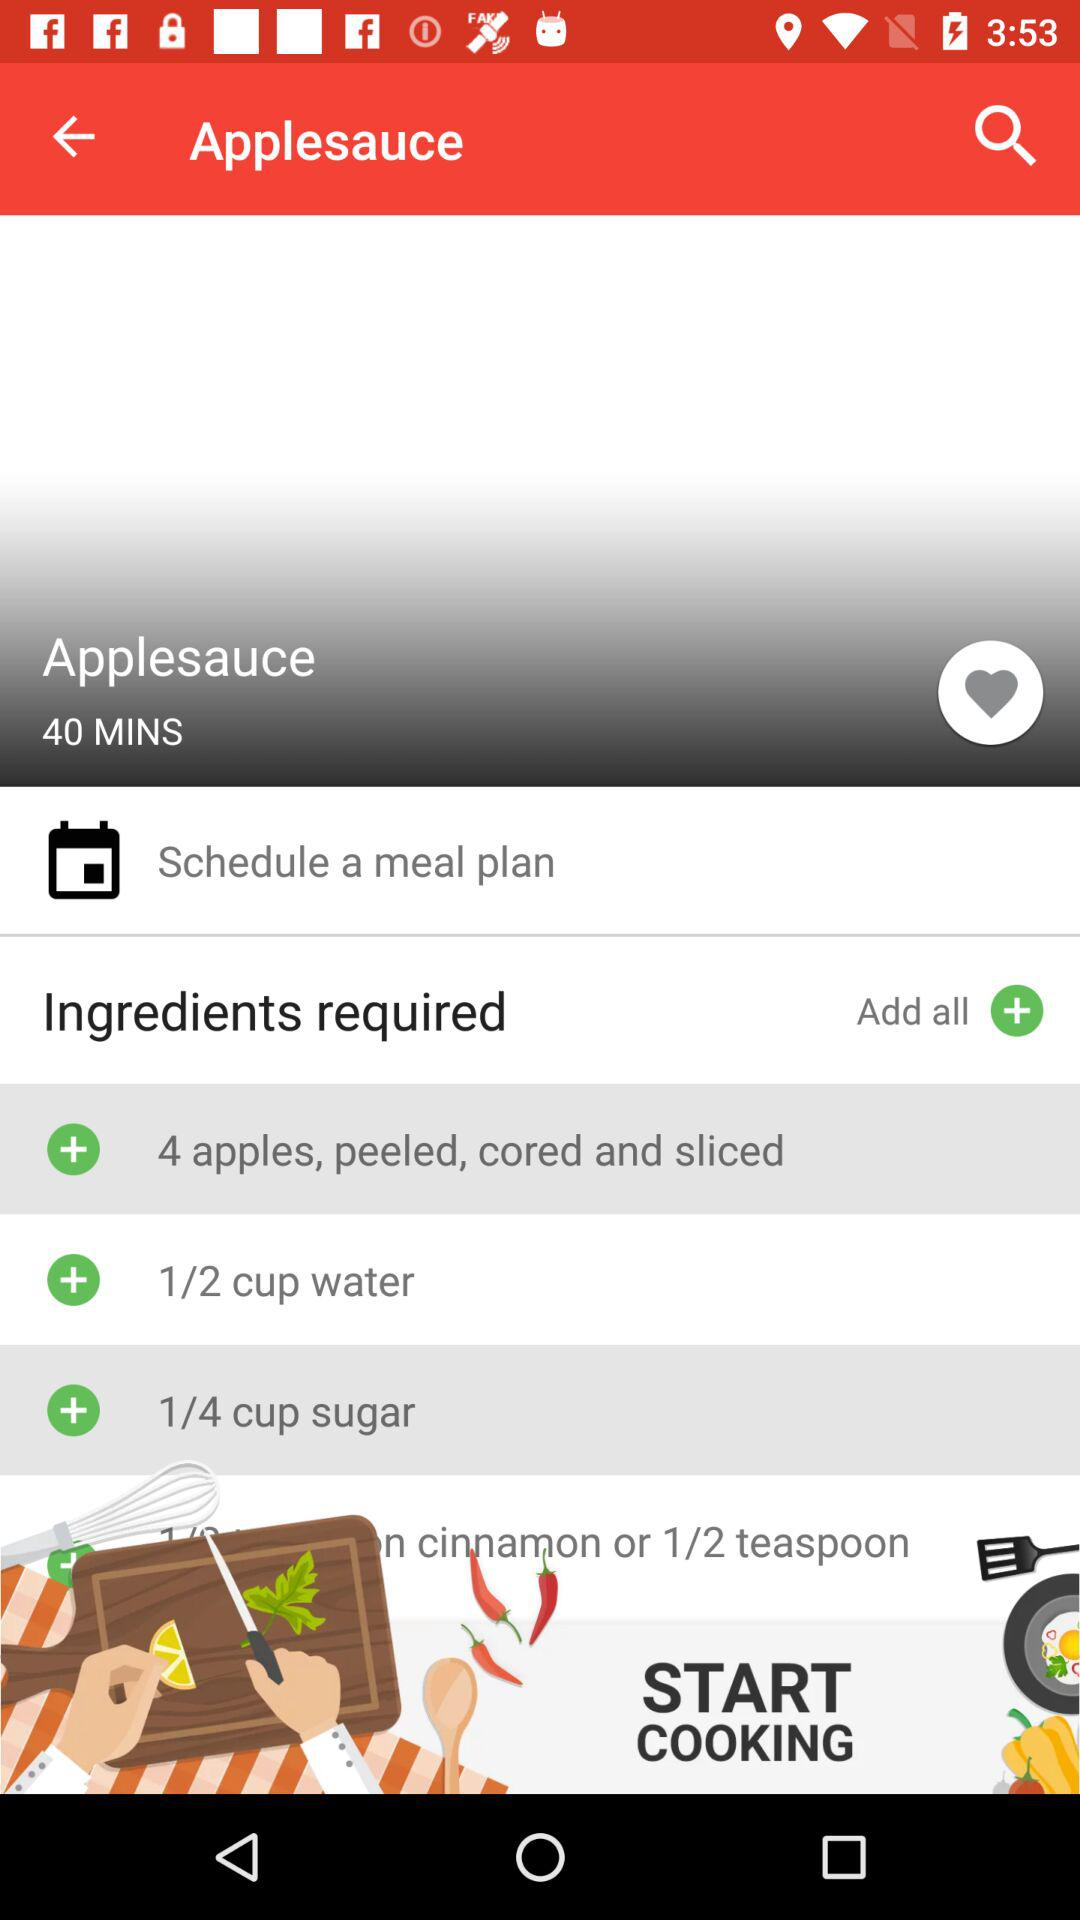How many ingredients are required to make applesauce?
Answer the question using a single word or phrase. 4 